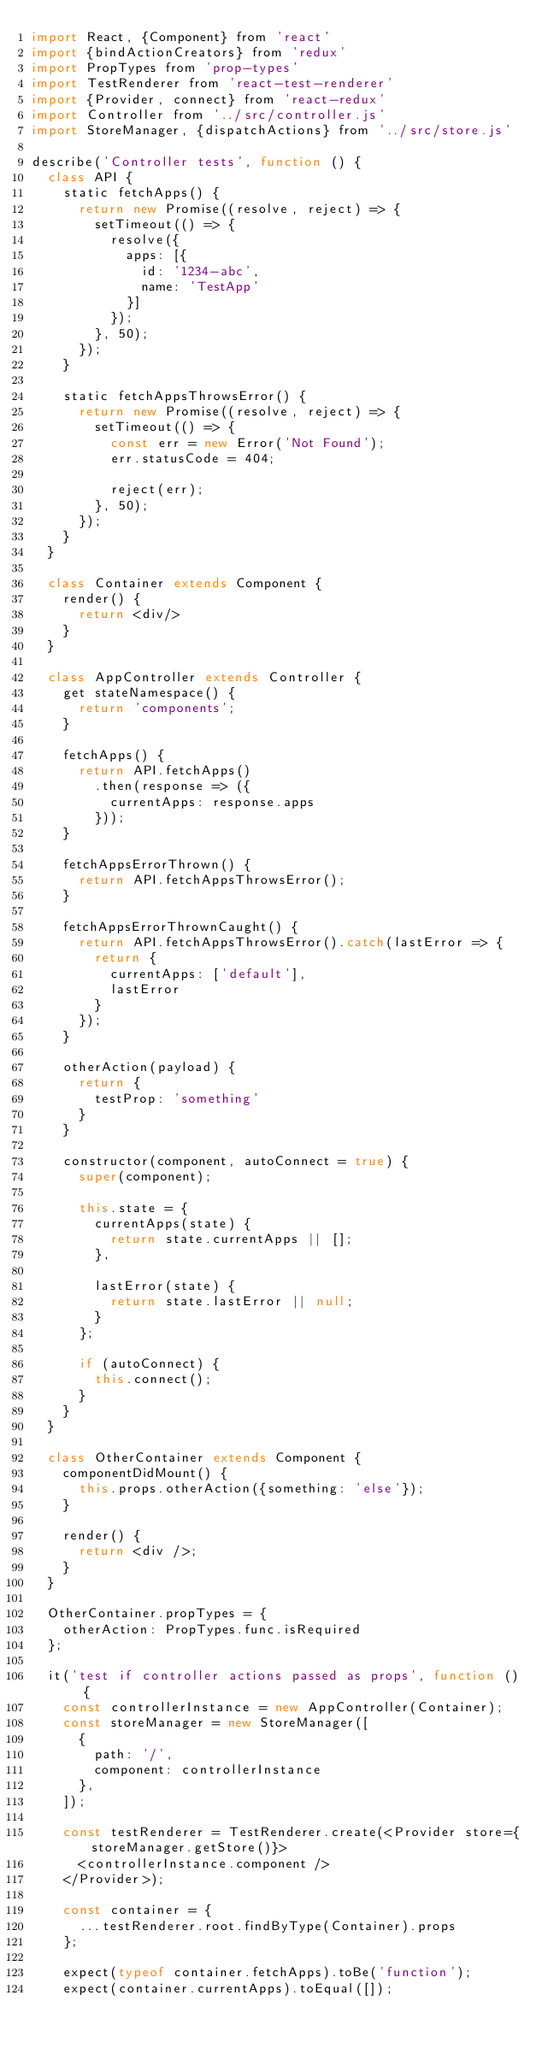<code> <loc_0><loc_0><loc_500><loc_500><_JavaScript_>import React, {Component} from 'react'
import {bindActionCreators} from 'redux'
import PropTypes from 'prop-types'
import TestRenderer from 'react-test-renderer'
import {Provider, connect} from 'react-redux'
import Controller from '../src/controller.js'
import StoreManager, {dispatchActions} from '../src/store.js'

describe('Controller tests', function () {
  class API {
    static fetchApps() {
      return new Promise((resolve, reject) => {
        setTimeout(() => {
          resolve({
            apps: [{
              id: '1234-abc',
              name: 'TestApp'
            }]
          });
        }, 50);
      });
    }

    static fetchAppsThrowsError() {
      return new Promise((resolve, reject) => {
        setTimeout(() => {
          const err = new Error('Not Found');
          err.statusCode = 404;

          reject(err);
        }, 50);
      });
    }
  }

  class Container extends Component {
    render() {
      return <div/>
    }
  }

  class AppController extends Controller {
    get stateNamespace() {
      return 'components';
    }

    fetchApps() {
      return API.fetchApps()
        .then(response => ({
          currentApps: response.apps
        }));
    }

    fetchAppsErrorThrown() {
      return API.fetchAppsThrowsError();
    }

    fetchAppsErrorThrownCaught() {
      return API.fetchAppsThrowsError().catch(lastError => {
        return {
          currentApps: ['default'],
          lastError
        }
      });
    }

    otherAction(payload) {
      return {
        testProp: 'something'
      }
    }

    constructor(component, autoConnect = true) {
      super(component);

      this.state = {
        currentApps(state) {
          return state.currentApps || [];
        },

        lastError(state) {
          return state.lastError || null;
        }
      };

      if (autoConnect) {
        this.connect();
      }
    }
  }

  class OtherContainer extends Component {
    componentDidMount() {
      this.props.otherAction({something: 'else'});
    }

    render() {
      return <div />;
    }
  }

  OtherContainer.propTypes = {
    otherAction: PropTypes.func.isRequired
  };

  it('test if controller actions passed as props', function () {
    const controllerInstance = new AppController(Container);
    const storeManager = new StoreManager([
      {
        path: '/',
        component: controllerInstance
      },
    ]);

    const testRenderer = TestRenderer.create(<Provider store={storeManager.getStore()}>
      <controllerInstance.component />
    </Provider>);

    const container = {
      ...testRenderer.root.findByType(Container).props
    };

    expect(typeof container.fetchApps).toBe('function');
    expect(container.currentApps).toEqual([]);</code> 